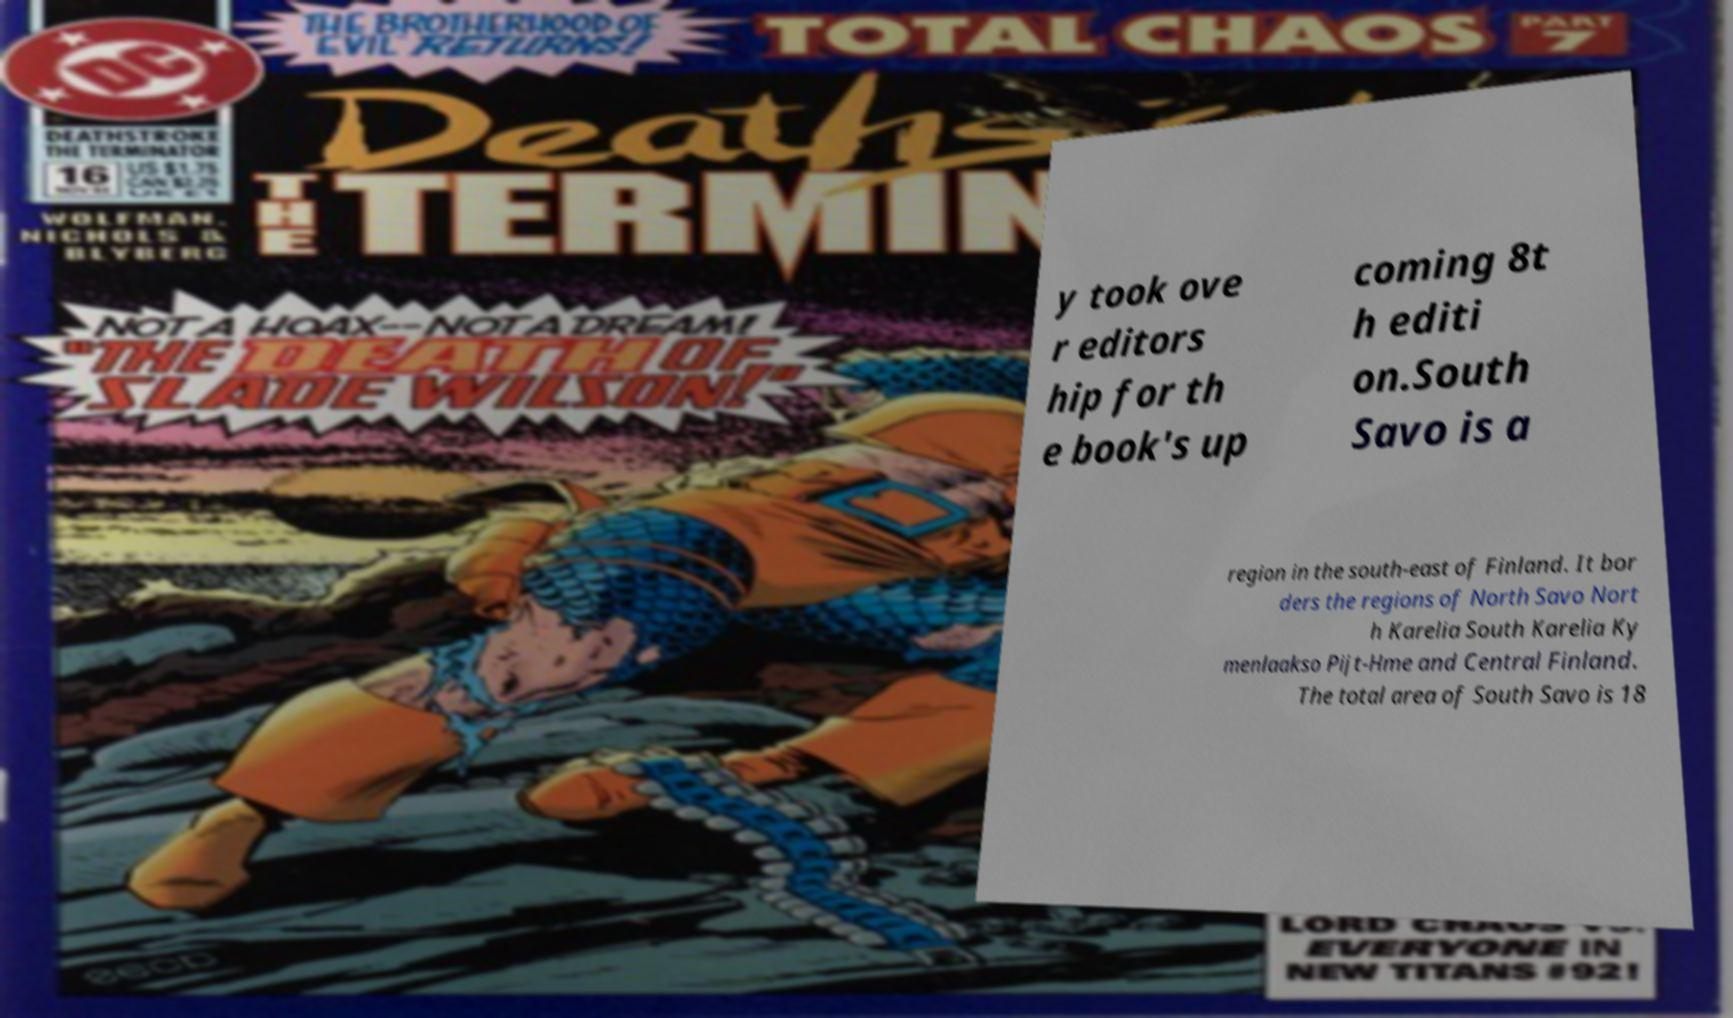Could you extract and type out the text from this image? y took ove r editors hip for th e book's up coming 8t h editi on.South Savo is a region in the south-east of Finland. It bor ders the regions of North Savo Nort h Karelia South Karelia Ky menlaakso Pijt-Hme and Central Finland. The total area of South Savo is 18 